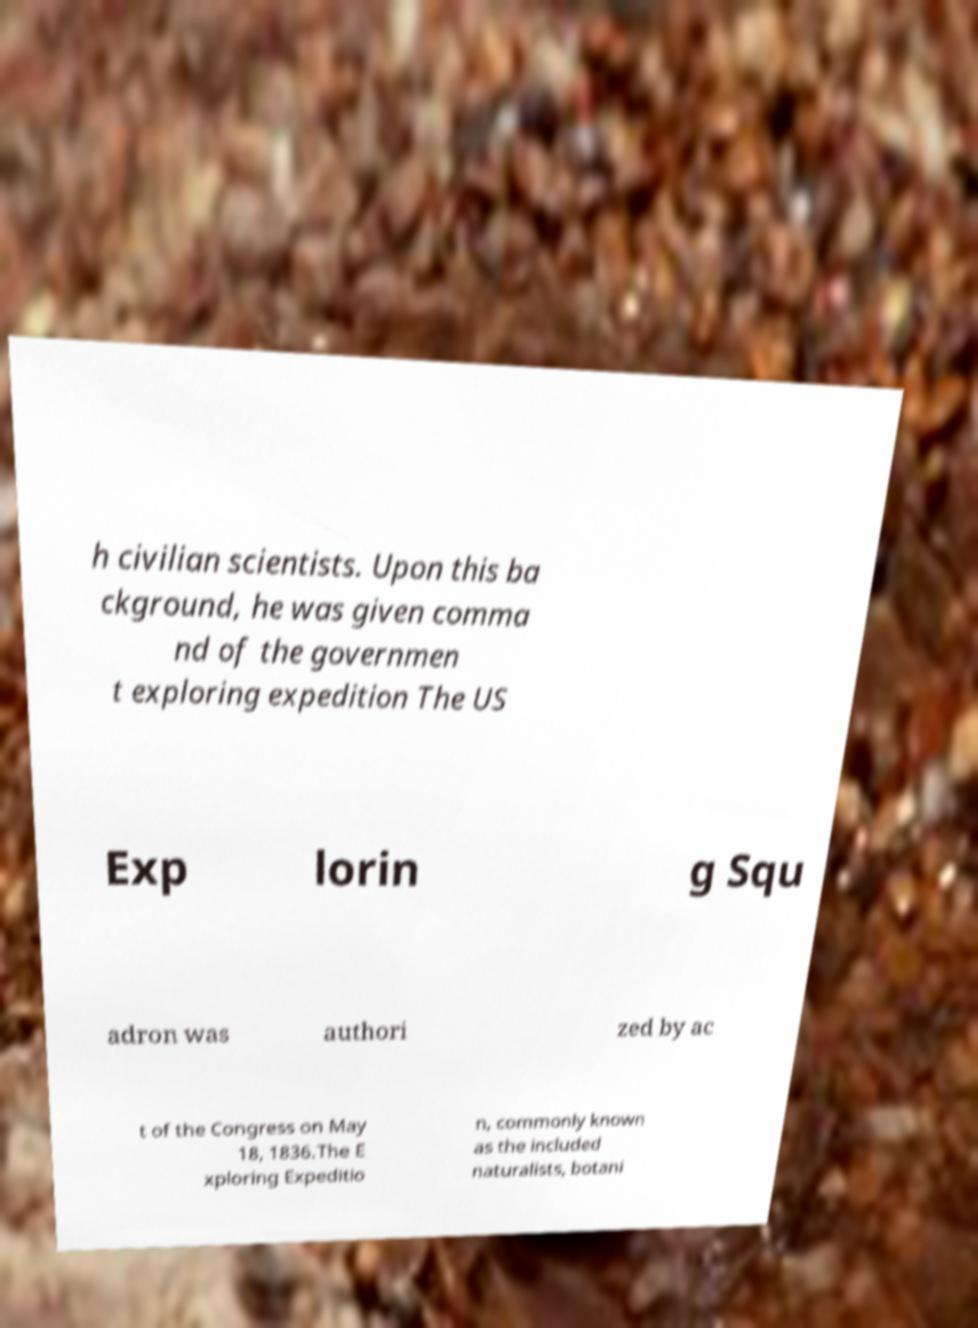There's text embedded in this image that I need extracted. Can you transcribe it verbatim? h civilian scientists. Upon this ba ckground, he was given comma nd of the governmen t exploring expedition The US Exp lorin g Squ adron was authori zed by ac t of the Congress on May 18, 1836.The E xploring Expeditio n, commonly known as the included naturalists, botani 